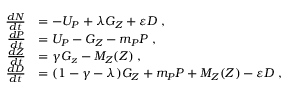<formula> <loc_0><loc_0><loc_500><loc_500>\begin{array} { r l } { \frac { d N } { d t } } & { = - U _ { P } + \lambda G _ { Z } + \varepsilon D \, , } \\ { \frac { d P } { d t } } & { = U _ { P } - G _ { Z } - m _ { P } P \, , } \\ { \frac { d Z } { d t } } & { = \gamma G _ { z } - M _ { Z } ( Z ) \, , } \\ { \frac { d D } { d t } } & { = ( 1 - \gamma - \lambda ) G _ { Z } + m _ { P } P + M _ { Z } ( Z ) - \varepsilon D \, , } \end{array}</formula> 